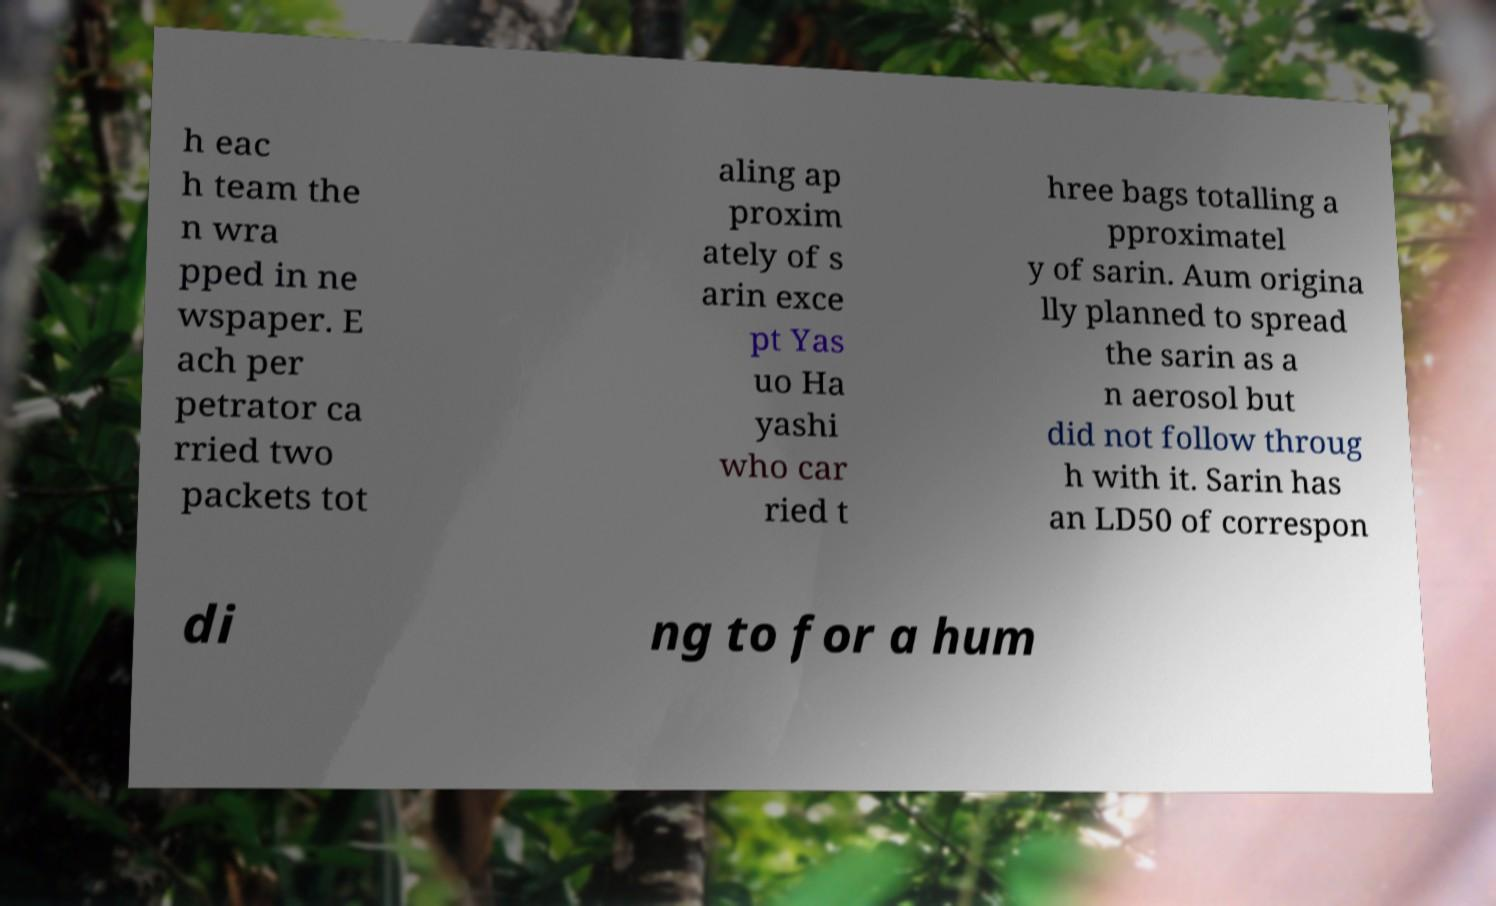I need the written content from this picture converted into text. Can you do that? h eac h team the n wra pped in ne wspaper. E ach per petrator ca rried two packets tot aling ap proxim ately of s arin exce pt Yas uo Ha yashi who car ried t hree bags totalling a pproximatel y of sarin. Aum origina lly planned to spread the sarin as a n aerosol but did not follow throug h with it. Sarin has an LD50 of correspon di ng to for a hum 